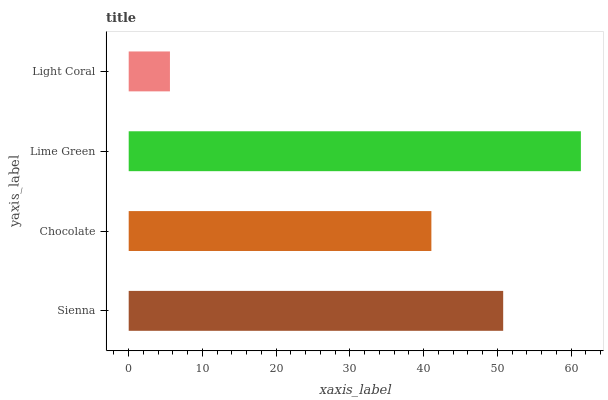Is Light Coral the minimum?
Answer yes or no. Yes. Is Lime Green the maximum?
Answer yes or no. Yes. Is Chocolate the minimum?
Answer yes or no. No. Is Chocolate the maximum?
Answer yes or no. No. Is Sienna greater than Chocolate?
Answer yes or no. Yes. Is Chocolate less than Sienna?
Answer yes or no. Yes. Is Chocolate greater than Sienna?
Answer yes or no. No. Is Sienna less than Chocolate?
Answer yes or no. No. Is Sienna the high median?
Answer yes or no. Yes. Is Chocolate the low median?
Answer yes or no. Yes. Is Lime Green the high median?
Answer yes or no. No. Is Lime Green the low median?
Answer yes or no. No. 